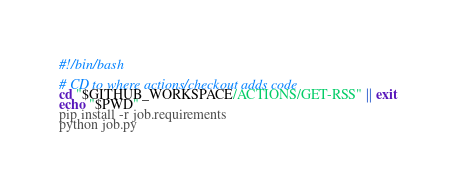<code> <loc_0><loc_0><loc_500><loc_500><_Bash_>#!/bin/bash

# CD to where actions/checkout adds code
cd "$GITHUB_WORKSPACE/ACTIONS/GET-RSS" || exit
echo "$PWD"
pip install -r job.requirements
python job.py</code> 